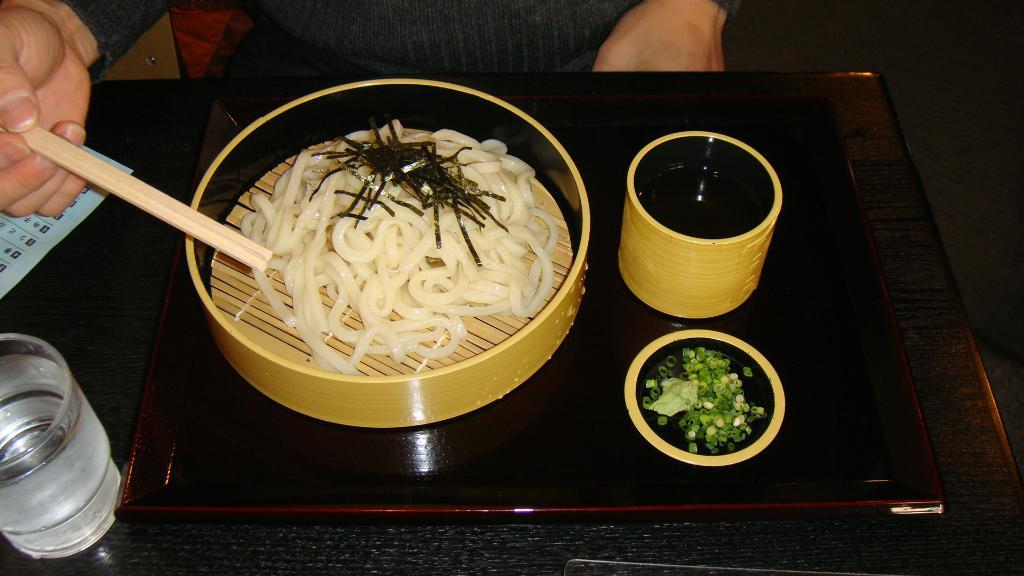What piece of furniture is present in the image? There is a table in the image. What is placed on the table? There is a glass and a bowl with a food item on the table. Are there any other items on the table? Yes, there are some other things on the table to the side. Can you see any crooks or mice in the image? No, there are no crooks or mice present in the image. 